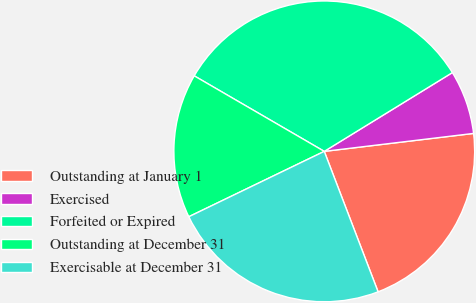Convert chart to OTSL. <chart><loc_0><loc_0><loc_500><loc_500><pie_chart><fcel>Outstanding at January 1<fcel>Exercised<fcel>Forfeited or Expired<fcel>Outstanding at December 31<fcel>Exercisable at December 31<nl><fcel>21.08%<fcel>6.87%<fcel>32.85%<fcel>15.53%<fcel>23.67%<nl></chart> 